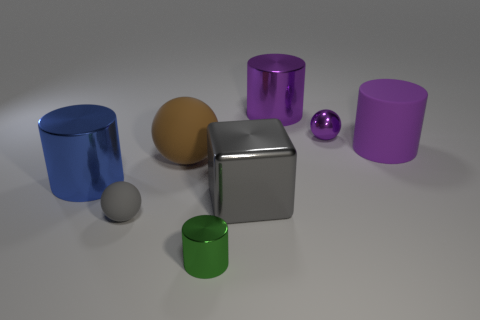What shape is the large gray thing that is the same material as the green cylinder?
Provide a succinct answer. Cube. What number of cylinders are both behind the green cylinder and to the left of the tiny purple object?
Keep it short and to the point. 2. Is there anything else that is the same shape as the large gray thing?
Ensure brevity in your answer.  No. What is the size of the metallic cube in front of the blue metallic object?
Offer a very short reply. Large. What number of other objects are there of the same color as the big rubber cylinder?
Your response must be concise. 2. There is a object to the left of the tiny ball to the left of the brown matte thing; what is its material?
Your answer should be very brief. Metal. There is a large metallic cylinder to the right of the big blue shiny object; is its color the same as the large rubber cylinder?
Make the answer very short. Yes. Is there anything else that is the same material as the green object?
Provide a short and direct response. Yes. What number of small green objects have the same shape as the tiny purple metal thing?
Offer a terse response. 0. The gray thing that is made of the same material as the big blue cylinder is what size?
Keep it short and to the point. Large. 